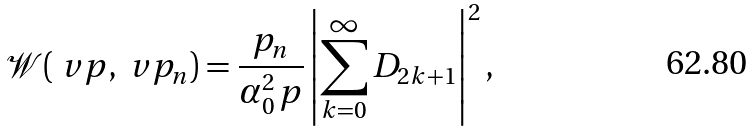<formula> <loc_0><loc_0><loc_500><loc_500>\mathcal { W } ( \ v p , \ v p _ { n } ) = \frac { p _ { n } } { \alpha _ { 0 } ^ { 2 } \, p } \left | \sum _ { k = 0 } ^ { \infty } D _ { 2 k + 1 } \right | ^ { 2 } ,</formula> 